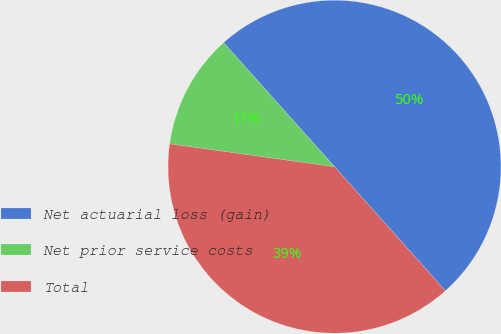Convert chart. <chart><loc_0><loc_0><loc_500><loc_500><pie_chart><fcel>Net actuarial loss (gain)<fcel>Net prior service costs<fcel>Total<nl><fcel>50.0%<fcel>11.2%<fcel>38.8%<nl></chart> 